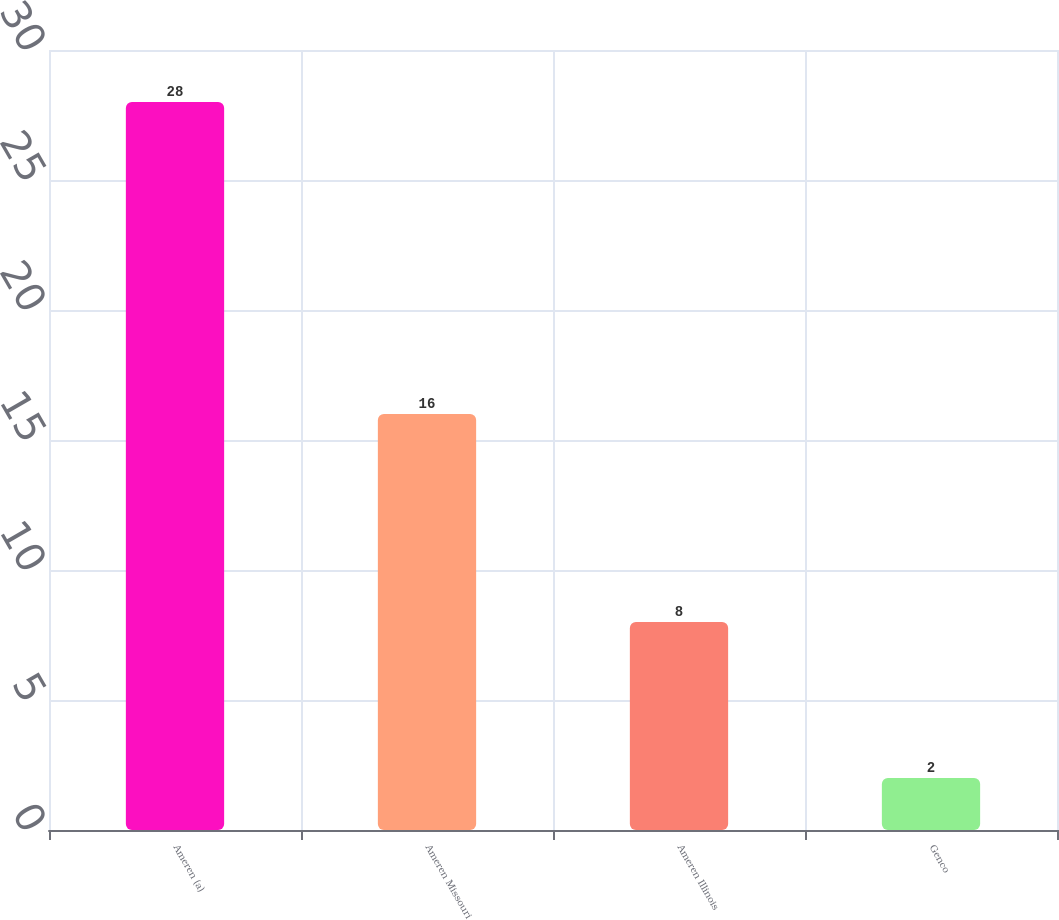Convert chart. <chart><loc_0><loc_0><loc_500><loc_500><bar_chart><fcel>Ameren (a)<fcel>Ameren Missouri<fcel>Ameren Illinois<fcel>Genco<nl><fcel>28<fcel>16<fcel>8<fcel>2<nl></chart> 